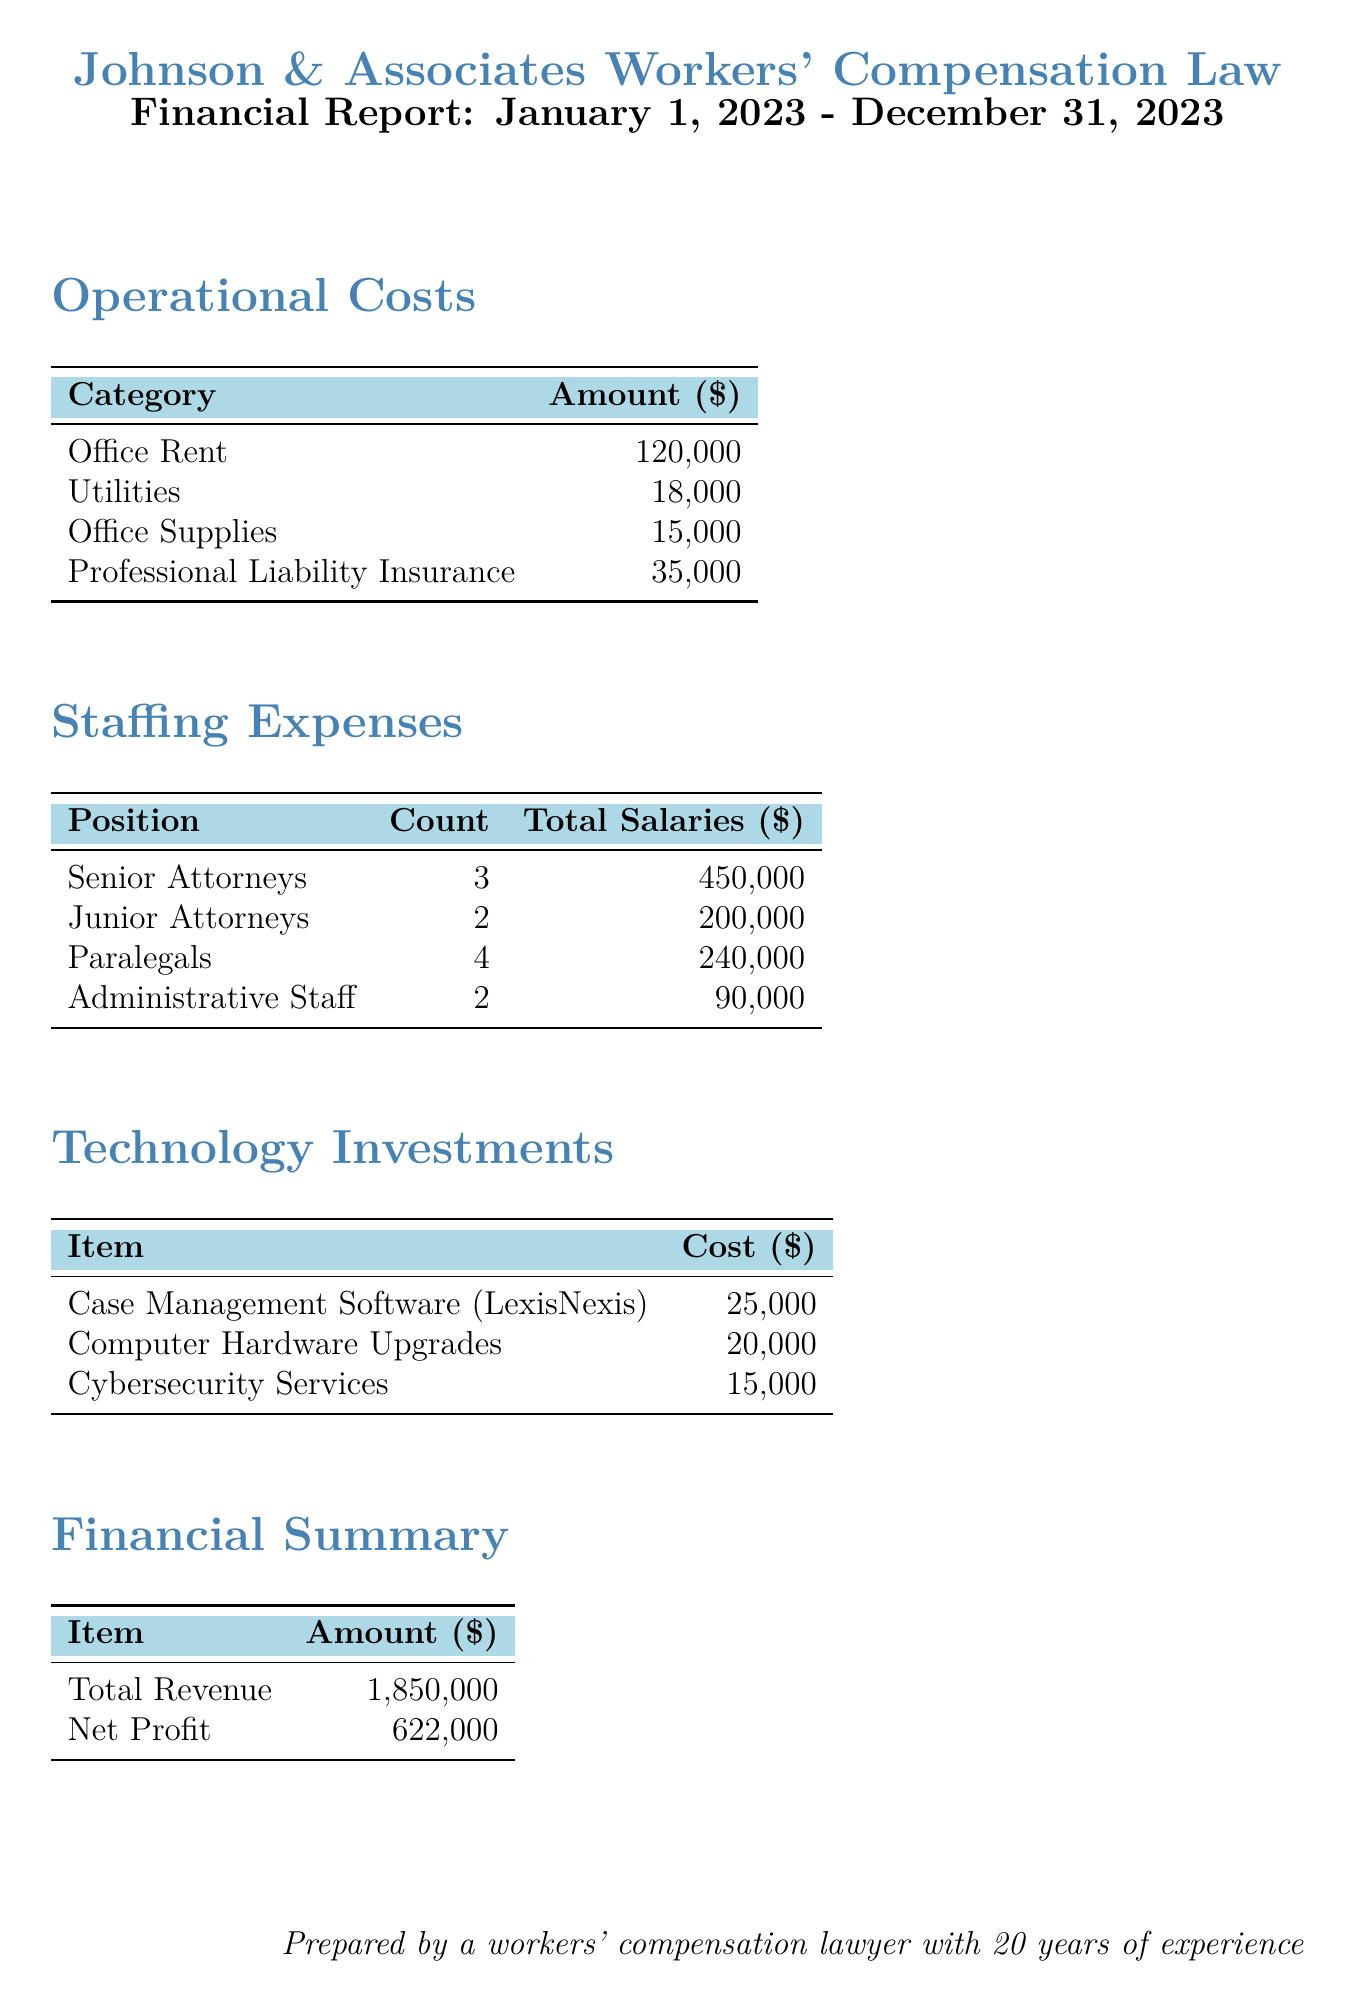what are the total operational costs? The total operational costs are the sum of all listed operational categories: Office Rent, Utilities, Office Supplies, and Professional Liability Insurance. This totals $120,000 + $18,000 + $15,000 + $35,000 = $188,000.
Answer: $188,000 how many senior attorneys are employed? The document states there are 3 senior attorneys listed under staffing expenses.
Answer: 3 what is the amount spent on office supplies? The document indicates that $15,000 was spent on office supplies under operational costs.
Answer: $15,000 how much is invested in technology overall? The overall investment in technology is the sum of the costs of Case Management Software, Computer Hardware Upgrades, and Cybersecurity Services, which totals $25,000 + $20,000 + $15,000 = $60,000.
Answer: $60,000 what are the total salaries for junior attorneys? The total salaries for junior attorneys is specifically mentioned as $200,000 in the staffing expenses section.
Answer: $200,000 what is the net profit reported? The net profit is specified in the financial summary as $622,000.
Answer: $622,000 how much is spent on professional liability insurance? The document details a cost of $35,000 for professional liability insurance under operational costs.
Answer: $35,000 what is the count of paralegals in the firm? The staffing expenses section lists a total of 4 paralegals.
Answer: 4 what percentage of total revenue is represented by staffing expenses? Total staffing expenses totaled $1,000,000, and dividing this by the total revenue of $1,850,000 gives approximately 54%.
Answer: 54% 